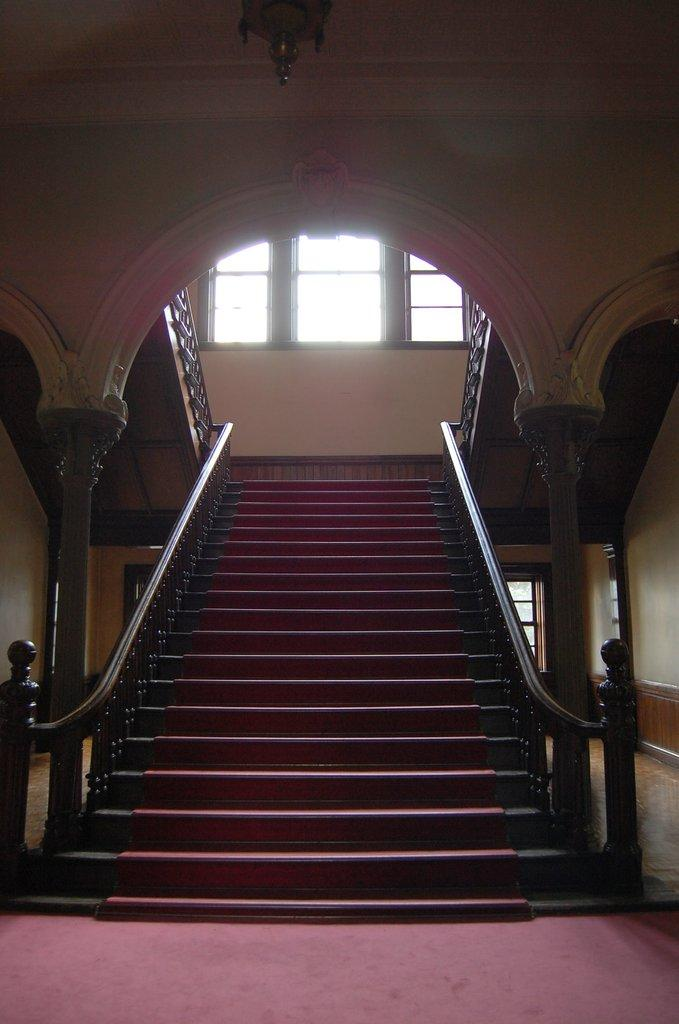What type of location is depicted in the image? The image shows an inside view of a building. What architectural feature can be seen in the image? There are steps in the image. What allows natural light to enter the building in the image? There are windows in the image. How many boys are visible in the image? There are no boys present in the image. Is there a stranger standing on the roof in the image? There is no roof visible in the image, and therefore no stranger can be standing on it. 